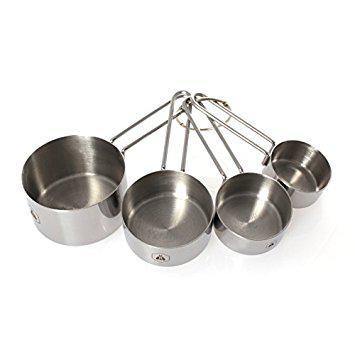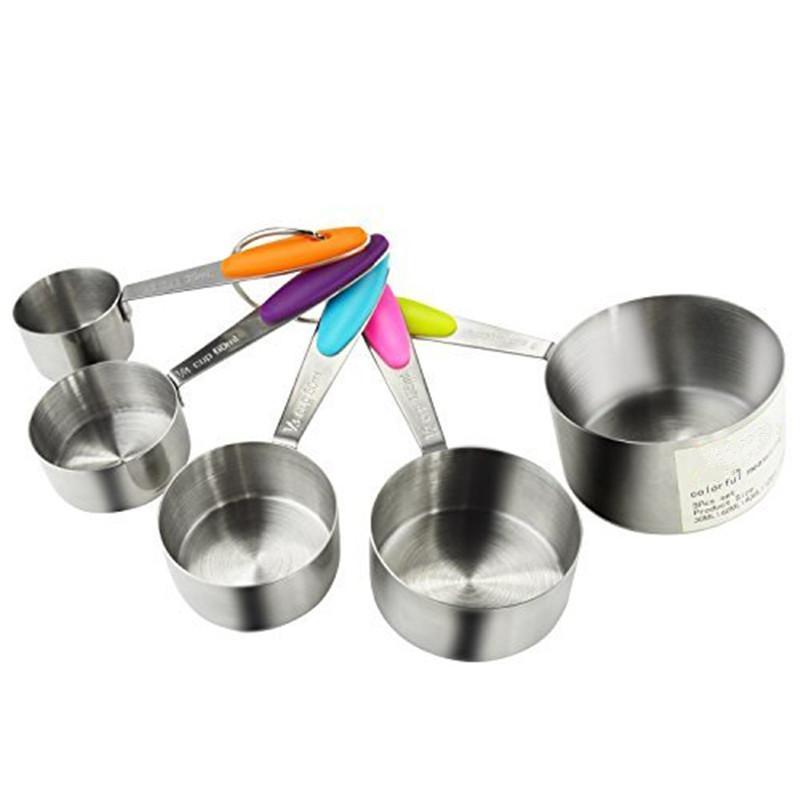The first image is the image on the left, the second image is the image on the right. Assess this claim about the two images: "There are five measuring cups in the right image". Correct or not? Answer yes or no. Yes. 